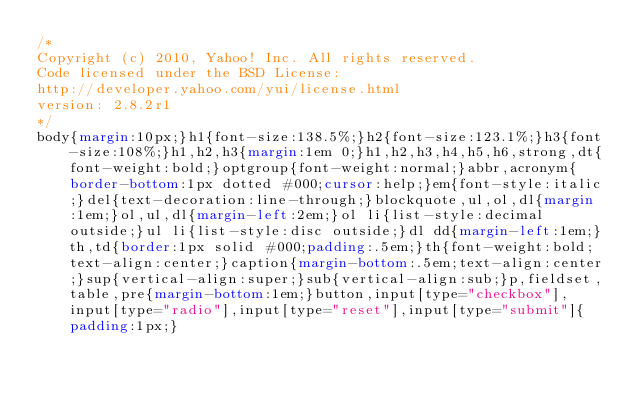Convert code to text. <code><loc_0><loc_0><loc_500><loc_500><_CSS_>/*
Copyright (c) 2010, Yahoo! Inc. All rights reserved.
Code licensed under the BSD License:
http://developer.yahoo.com/yui/license.html
version: 2.8.2r1
*/
body{margin:10px;}h1{font-size:138.5%;}h2{font-size:123.1%;}h3{font-size:108%;}h1,h2,h3{margin:1em 0;}h1,h2,h3,h4,h5,h6,strong,dt{font-weight:bold;}optgroup{font-weight:normal;}abbr,acronym{border-bottom:1px dotted #000;cursor:help;}em{font-style:italic;}del{text-decoration:line-through;}blockquote,ul,ol,dl{margin:1em;}ol,ul,dl{margin-left:2em;}ol li{list-style:decimal outside;}ul li{list-style:disc outside;}dl dd{margin-left:1em;}th,td{border:1px solid #000;padding:.5em;}th{font-weight:bold;text-align:center;}caption{margin-bottom:.5em;text-align:center;}sup{vertical-align:super;}sub{vertical-align:sub;}p,fieldset,table,pre{margin-bottom:1em;}button,input[type="checkbox"],input[type="radio"],input[type="reset"],input[type="submit"]{padding:1px;}
</code> 